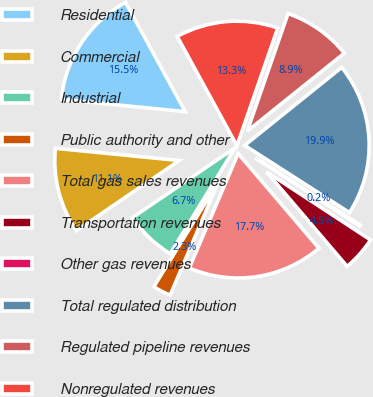Convert chart. <chart><loc_0><loc_0><loc_500><loc_500><pie_chart><fcel>Residential<fcel>Commercial<fcel>Industrial<fcel>Public authority and other<fcel>Total gas sales revenues<fcel>Transportation revenues<fcel>Other gas revenues<fcel>Total regulated distribution<fcel>Regulated pipeline revenues<fcel>Nonregulated revenues<nl><fcel>15.47%<fcel>11.09%<fcel>6.72%<fcel>2.34%<fcel>17.66%<fcel>4.53%<fcel>0.15%<fcel>19.85%<fcel>8.91%<fcel>13.28%<nl></chart> 